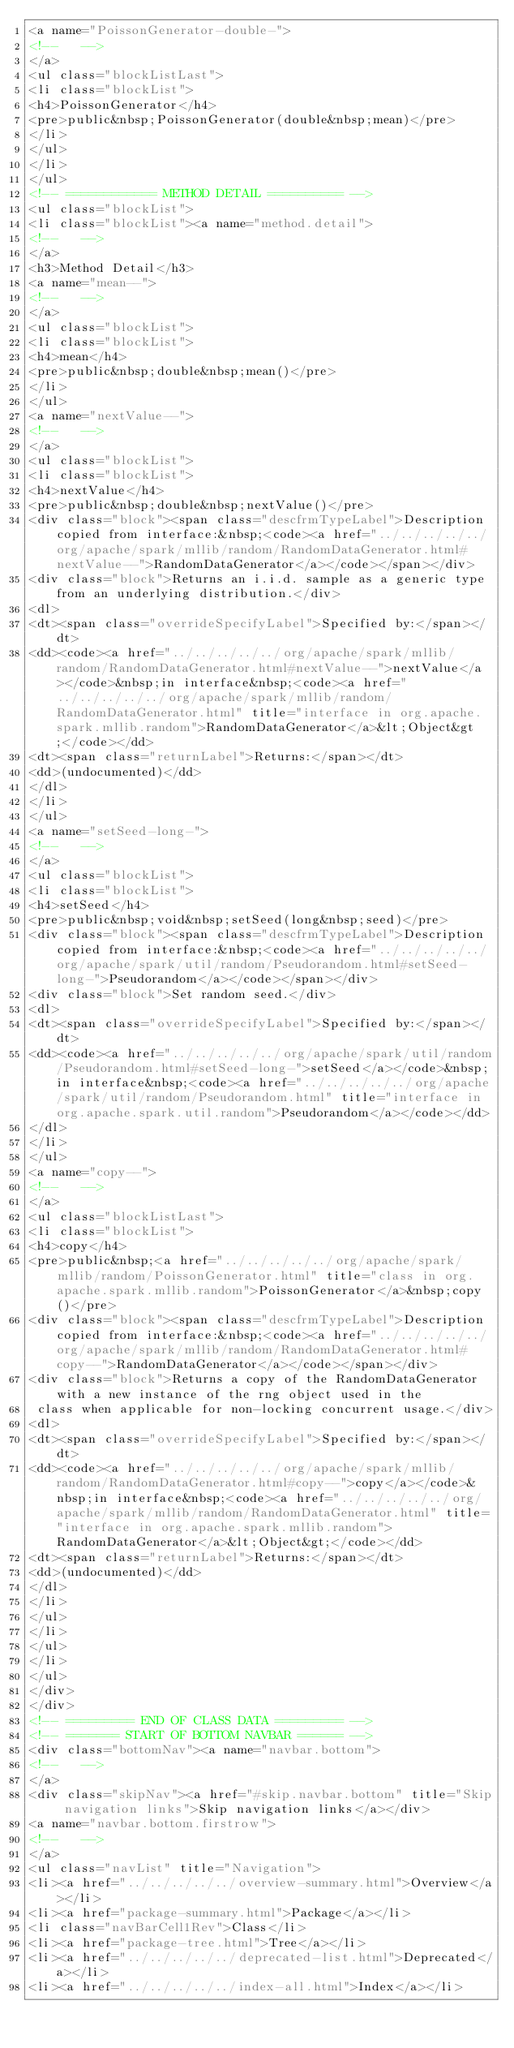<code> <loc_0><loc_0><loc_500><loc_500><_HTML_><a name="PoissonGenerator-double-">
<!--   -->
</a>
<ul class="blockListLast">
<li class="blockList">
<h4>PoissonGenerator</h4>
<pre>public&nbsp;PoissonGenerator(double&nbsp;mean)</pre>
</li>
</ul>
</li>
</ul>
<!-- ============ METHOD DETAIL ========== -->
<ul class="blockList">
<li class="blockList"><a name="method.detail">
<!--   -->
</a>
<h3>Method Detail</h3>
<a name="mean--">
<!--   -->
</a>
<ul class="blockList">
<li class="blockList">
<h4>mean</h4>
<pre>public&nbsp;double&nbsp;mean()</pre>
</li>
</ul>
<a name="nextValue--">
<!--   -->
</a>
<ul class="blockList">
<li class="blockList">
<h4>nextValue</h4>
<pre>public&nbsp;double&nbsp;nextValue()</pre>
<div class="block"><span class="descfrmTypeLabel">Description copied from interface:&nbsp;<code><a href="../../../../../org/apache/spark/mllib/random/RandomDataGenerator.html#nextValue--">RandomDataGenerator</a></code></span></div>
<div class="block">Returns an i.i.d. sample as a generic type from an underlying distribution.</div>
<dl>
<dt><span class="overrideSpecifyLabel">Specified by:</span></dt>
<dd><code><a href="../../../../../org/apache/spark/mllib/random/RandomDataGenerator.html#nextValue--">nextValue</a></code>&nbsp;in interface&nbsp;<code><a href="../../../../../org/apache/spark/mllib/random/RandomDataGenerator.html" title="interface in org.apache.spark.mllib.random">RandomDataGenerator</a>&lt;Object&gt;</code></dd>
<dt><span class="returnLabel">Returns:</span></dt>
<dd>(undocumented)</dd>
</dl>
</li>
</ul>
<a name="setSeed-long-">
<!--   -->
</a>
<ul class="blockList">
<li class="blockList">
<h4>setSeed</h4>
<pre>public&nbsp;void&nbsp;setSeed(long&nbsp;seed)</pre>
<div class="block"><span class="descfrmTypeLabel">Description copied from interface:&nbsp;<code><a href="../../../../../org/apache/spark/util/random/Pseudorandom.html#setSeed-long-">Pseudorandom</a></code></span></div>
<div class="block">Set random seed.</div>
<dl>
<dt><span class="overrideSpecifyLabel">Specified by:</span></dt>
<dd><code><a href="../../../../../org/apache/spark/util/random/Pseudorandom.html#setSeed-long-">setSeed</a></code>&nbsp;in interface&nbsp;<code><a href="../../../../../org/apache/spark/util/random/Pseudorandom.html" title="interface in org.apache.spark.util.random">Pseudorandom</a></code></dd>
</dl>
</li>
</ul>
<a name="copy--">
<!--   -->
</a>
<ul class="blockListLast">
<li class="blockList">
<h4>copy</h4>
<pre>public&nbsp;<a href="../../../../../org/apache/spark/mllib/random/PoissonGenerator.html" title="class in org.apache.spark.mllib.random">PoissonGenerator</a>&nbsp;copy()</pre>
<div class="block"><span class="descfrmTypeLabel">Description copied from interface:&nbsp;<code><a href="../../../../../org/apache/spark/mllib/random/RandomDataGenerator.html#copy--">RandomDataGenerator</a></code></span></div>
<div class="block">Returns a copy of the RandomDataGenerator with a new instance of the rng object used in the
 class when applicable for non-locking concurrent usage.</div>
<dl>
<dt><span class="overrideSpecifyLabel">Specified by:</span></dt>
<dd><code><a href="../../../../../org/apache/spark/mllib/random/RandomDataGenerator.html#copy--">copy</a></code>&nbsp;in interface&nbsp;<code><a href="../../../../../org/apache/spark/mllib/random/RandomDataGenerator.html" title="interface in org.apache.spark.mllib.random">RandomDataGenerator</a>&lt;Object&gt;</code></dd>
<dt><span class="returnLabel">Returns:</span></dt>
<dd>(undocumented)</dd>
</dl>
</li>
</ul>
</li>
</ul>
</li>
</ul>
</div>
</div>
<!-- ========= END OF CLASS DATA ========= -->
<!-- ======= START OF BOTTOM NAVBAR ====== -->
<div class="bottomNav"><a name="navbar.bottom">
<!--   -->
</a>
<div class="skipNav"><a href="#skip.navbar.bottom" title="Skip navigation links">Skip navigation links</a></div>
<a name="navbar.bottom.firstrow">
<!--   -->
</a>
<ul class="navList" title="Navigation">
<li><a href="../../../../../overview-summary.html">Overview</a></li>
<li><a href="package-summary.html">Package</a></li>
<li class="navBarCell1Rev">Class</li>
<li><a href="package-tree.html">Tree</a></li>
<li><a href="../../../../../deprecated-list.html">Deprecated</a></li>
<li><a href="../../../../../index-all.html">Index</a></li></code> 